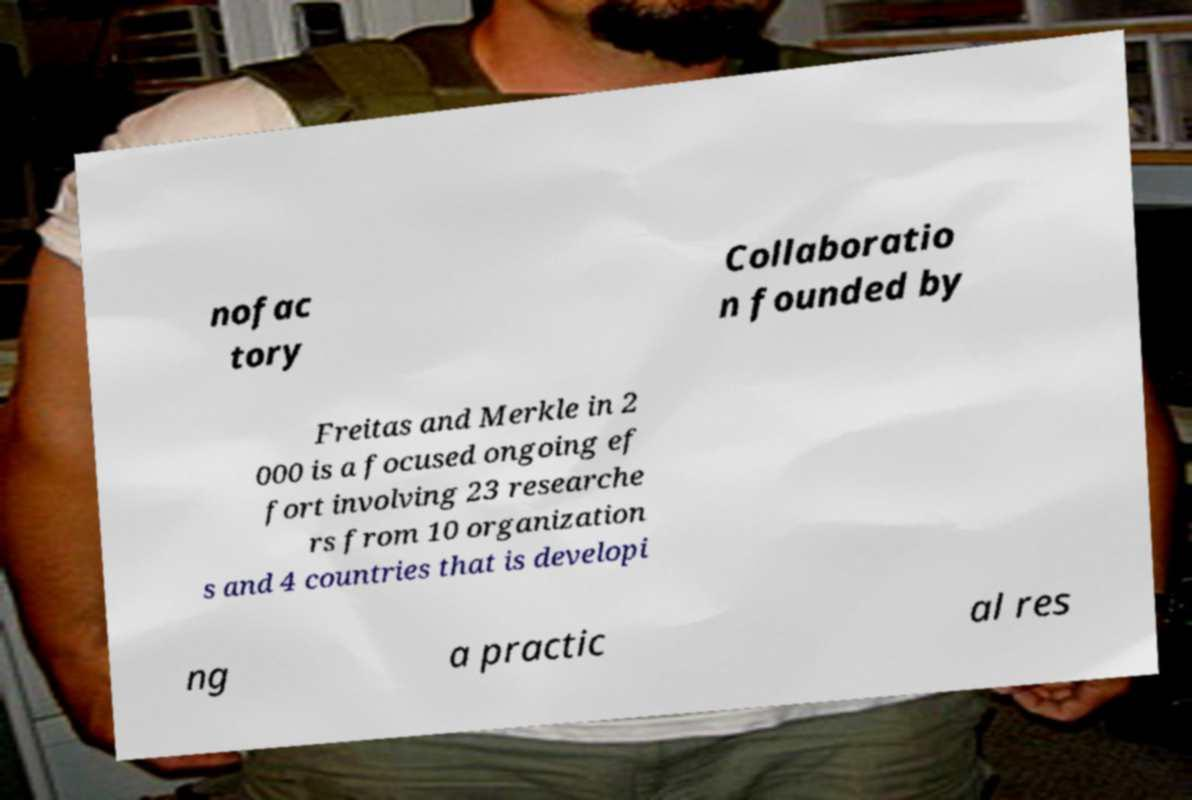Could you extract and type out the text from this image? nofac tory Collaboratio n founded by Freitas and Merkle in 2 000 is a focused ongoing ef fort involving 23 researche rs from 10 organization s and 4 countries that is developi ng a practic al res 